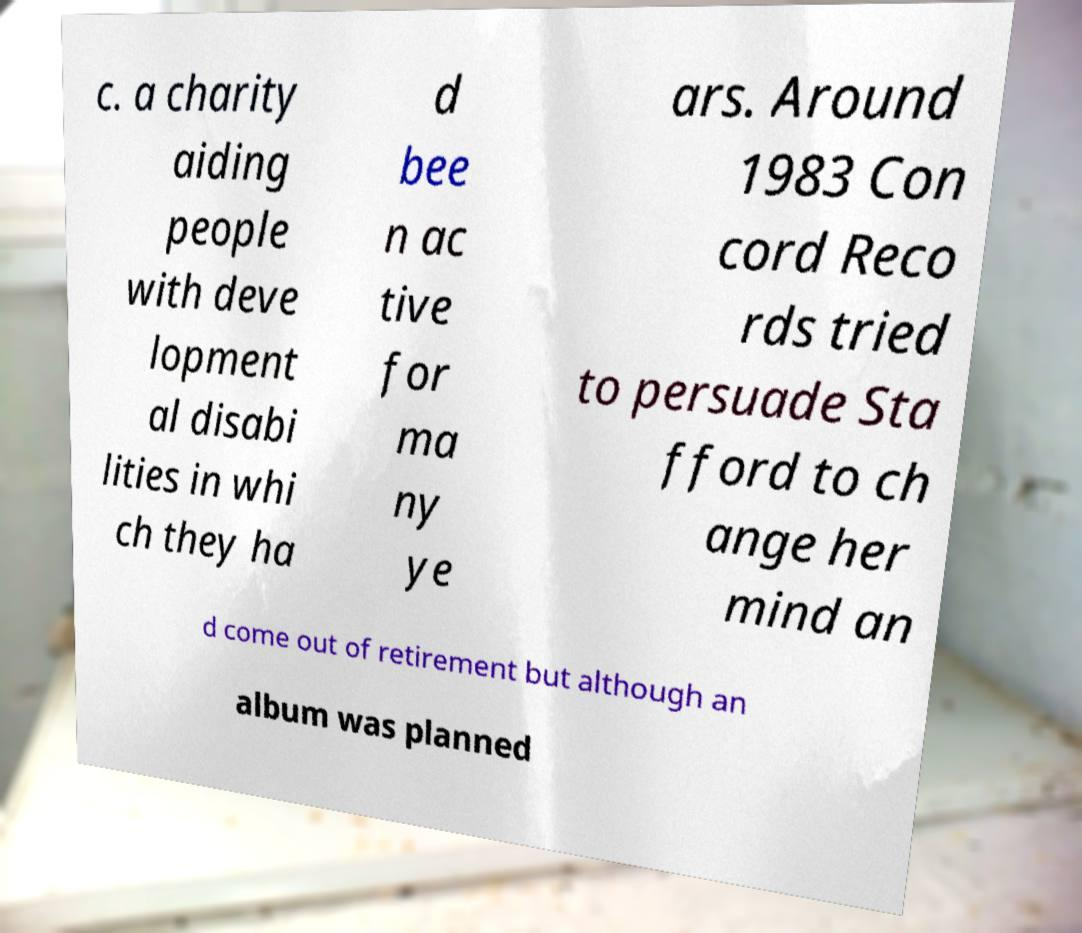I need the written content from this picture converted into text. Can you do that? c. a charity aiding people with deve lopment al disabi lities in whi ch they ha d bee n ac tive for ma ny ye ars. Around 1983 Con cord Reco rds tried to persuade Sta fford to ch ange her mind an d come out of retirement but although an album was planned 